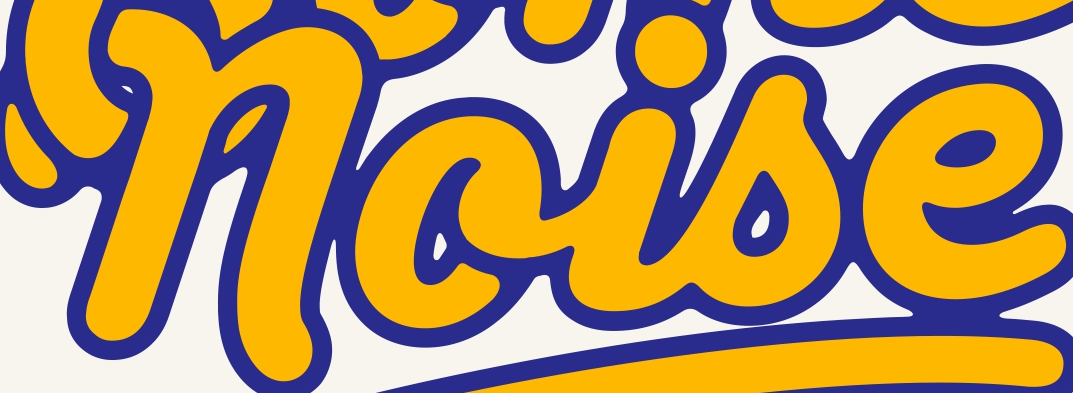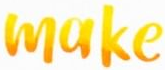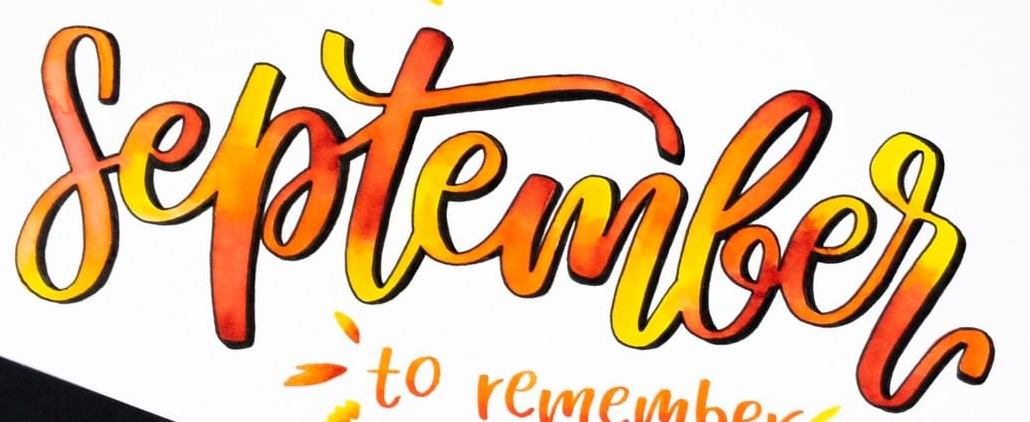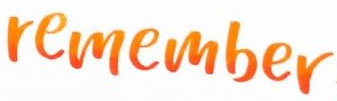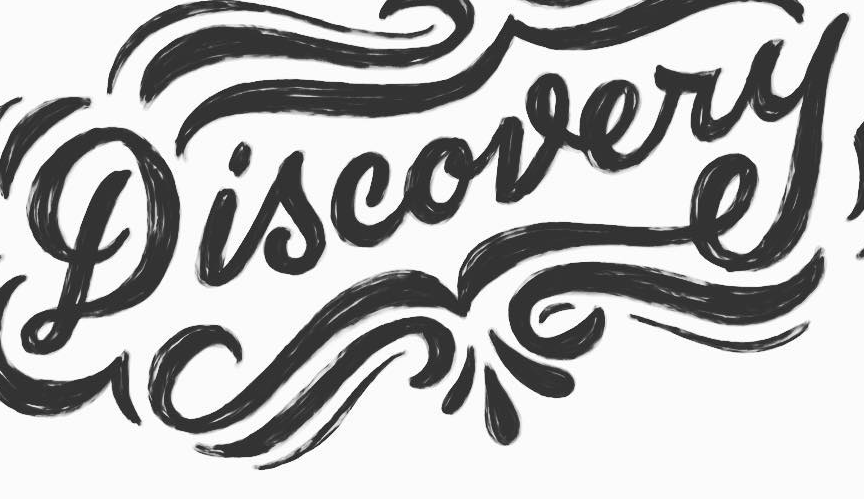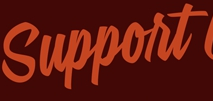Read the text content from these images in order, separated by a semicolon. noise; make; September; remember; Discovery; Support 